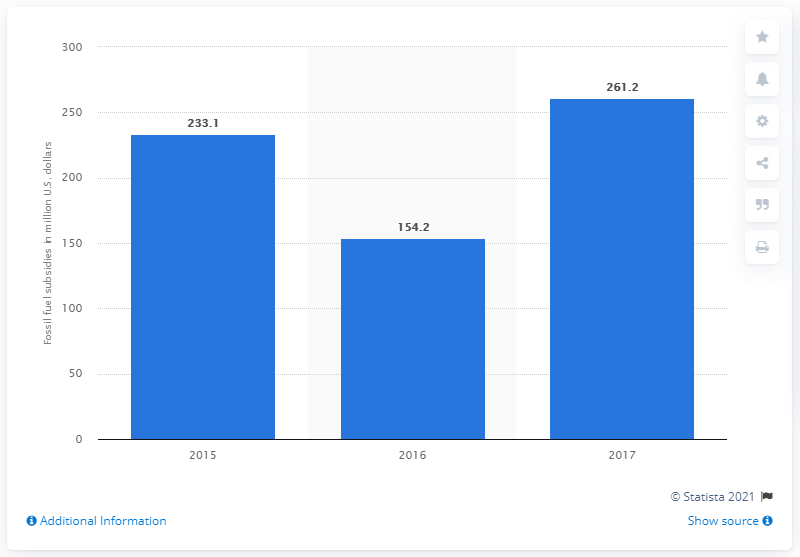Mention a couple of crucial points in this snapshot. In 2017, the value of fossil fuel subsidies in Vietnam was 261.2 million dollars. 